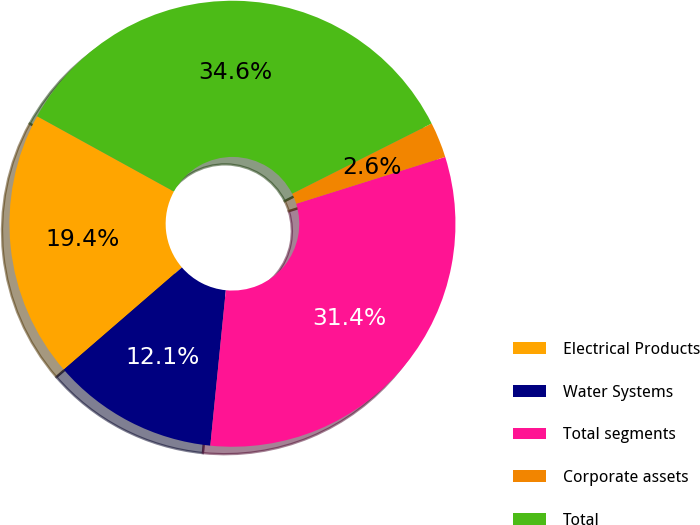Convert chart. <chart><loc_0><loc_0><loc_500><loc_500><pie_chart><fcel>Electrical Products<fcel>Water Systems<fcel>Total segments<fcel>Corporate assets<fcel>Total<nl><fcel>19.36%<fcel>12.07%<fcel>31.43%<fcel>2.58%<fcel>34.57%<nl></chart> 